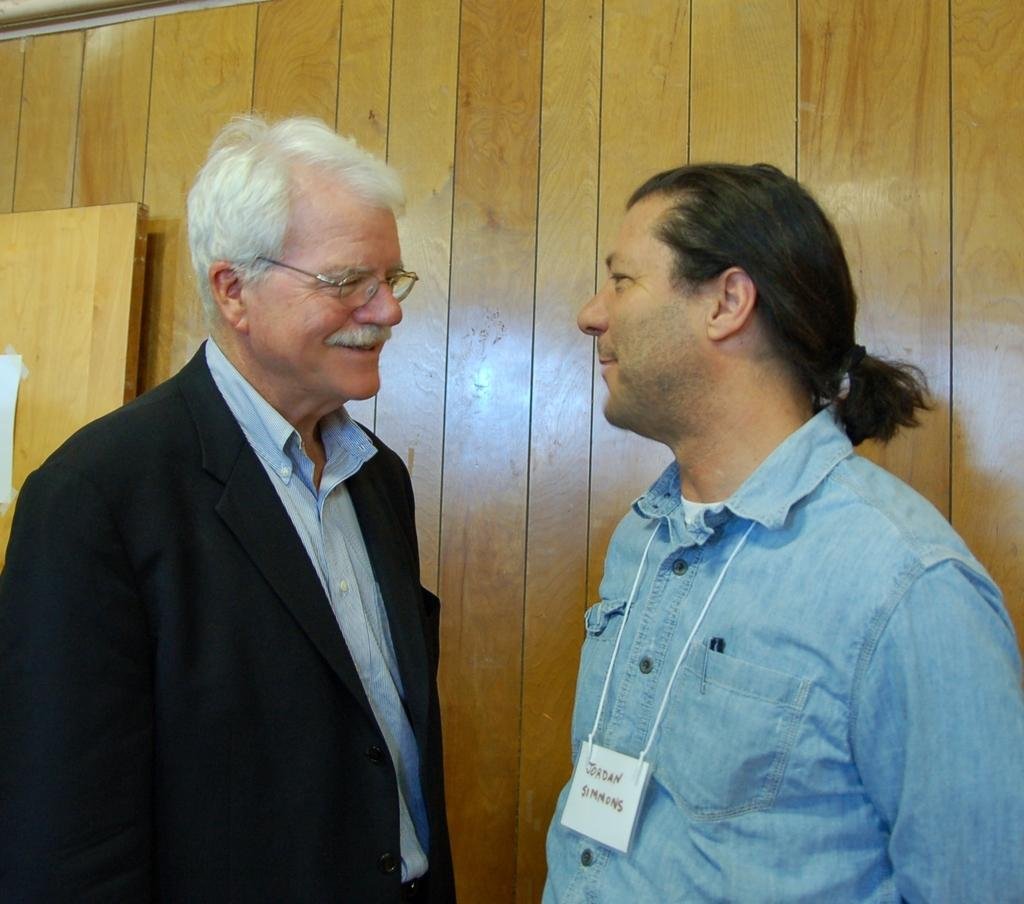How many people are present in the image? There are two men standing in the image. Can you describe the background of the image? There is a wooden wall in the background of the image. What type of cherries are being used to decorate the nation in the image? There are no cherries or any reference to a nation in the image, so it is not possible to answer that question. 